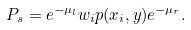Convert formula to latex. <formula><loc_0><loc_0><loc_500><loc_500>P _ { s } = e ^ { - \mu _ { l } } w _ { i } p ( x _ { i } , y ) e ^ { - \mu _ { r } } .</formula> 